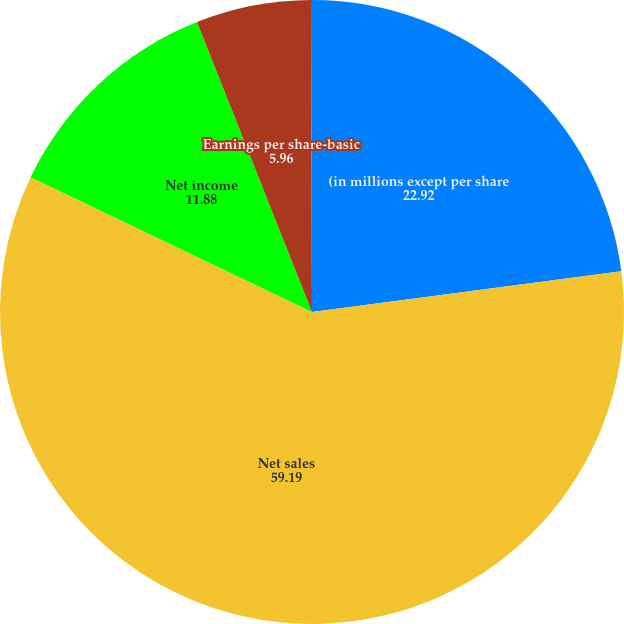<chart> <loc_0><loc_0><loc_500><loc_500><pie_chart><fcel>(in millions except per share<fcel>Net sales<fcel>Net income<fcel>Earnings per share-basic<fcel>Earnings per share-diluted<nl><fcel>22.92%<fcel>59.19%<fcel>11.88%<fcel>5.96%<fcel>0.05%<nl></chart> 